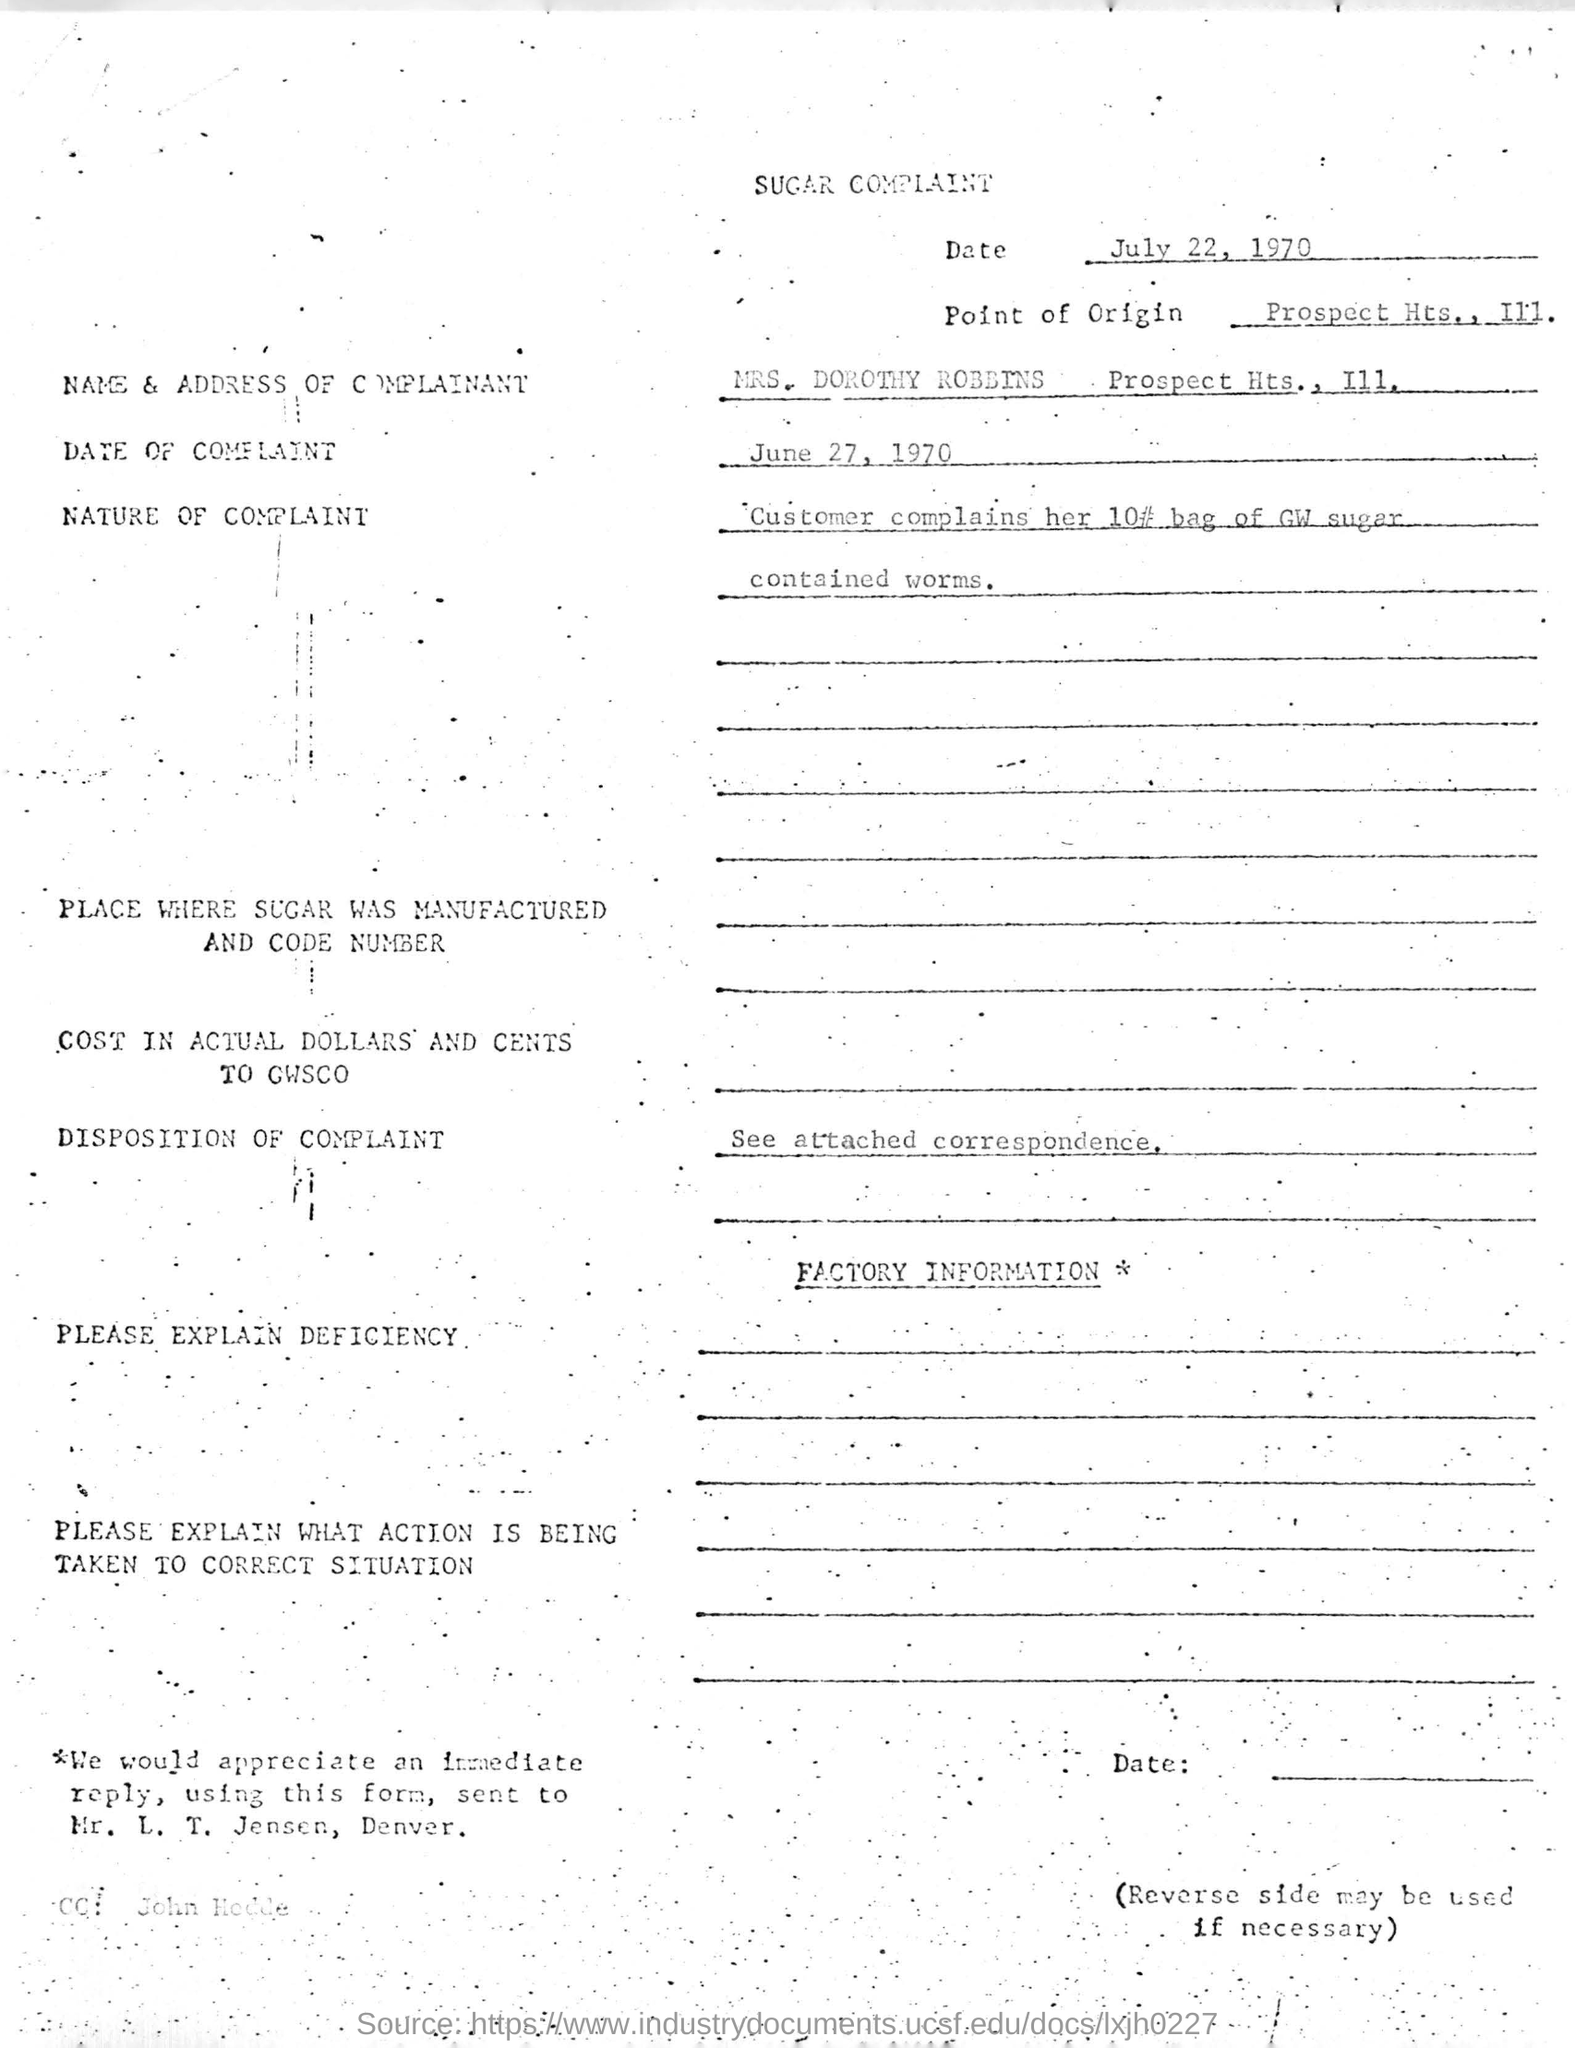Draw attention to some important aspects in this diagram. The bag of GW sugar contained worms. On June 27, 1970, the customer gave a complaint. The point of origin of the complaint is Prospect Hts., Illinois. 